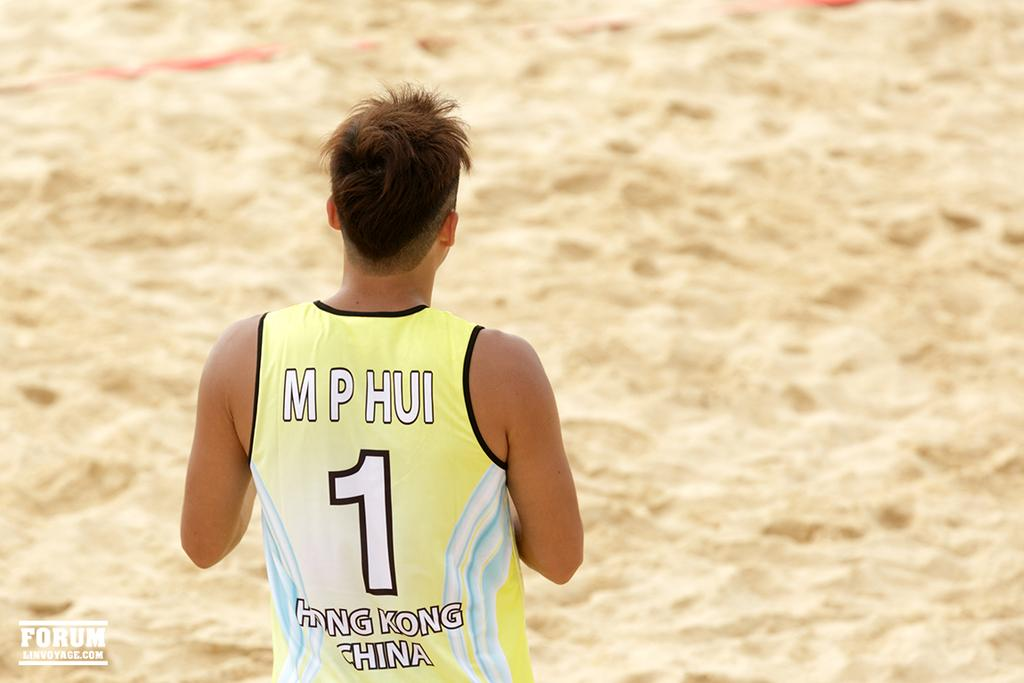<image>
Present a compact description of the photo's key features. a person wearing the number 1 on their jersey 